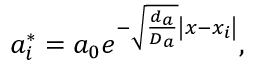Convert formula to latex. <formula><loc_0><loc_0><loc_500><loc_500>a _ { i } ^ { * } = a _ { 0 } e ^ { - \sqrt { \frac { d _ { a } } { D _ { a } } } \left | x - x _ { i } \right | } ,</formula> 